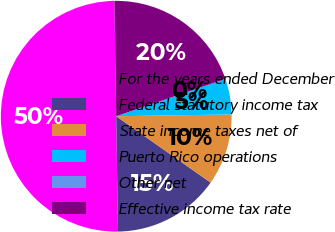Convert chart. <chart><loc_0><loc_0><loc_500><loc_500><pie_chart><fcel>For the years ended December<fcel>Federal statutory income tax<fcel>State income taxes net of<fcel>Puerto Rico operations<fcel>Other net<fcel>Effective income tax rate<nl><fcel>49.99%<fcel>15.0%<fcel>10.0%<fcel>5.0%<fcel>0.0%<fcel>20.0%<nl></chart> 